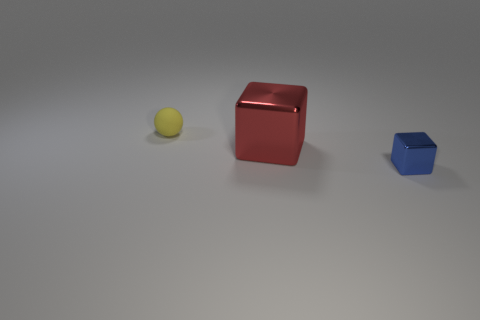There is a small object to the left of the small object to the right of the thing to the left of the big red block; what is its color?
Provide a short and direct response. Yellow. What number of metallic balls are there?
Your answer should be very brief. 0. What number of small objects are yellow matte things or blue blocks?
Your answer should be very brief. 2. What is the shape of the other object that is the same size as the yellow matte thing?
Give a very brief answer. Cube. Is there any other thing that is the same size as the red object?
Make the answer very short. No. There is a block left of the small object that is right of the red metallic block; what is it made of?
Your answer should be compact. Metal. Is the size of the matte object the same as the red metal block?
Provide a succinct answer. No. What number of things are objects behind the red cube or metal objects?
Provide a short and direct response. 3. There is a small thing behind the metal object to the right of the big red metallic object; what is its shape?
Your response must be concise. Sphere. There is a matte object; is it the same size as the metal object that is behind the blue metal block?
Provide a short and direct response. No. 